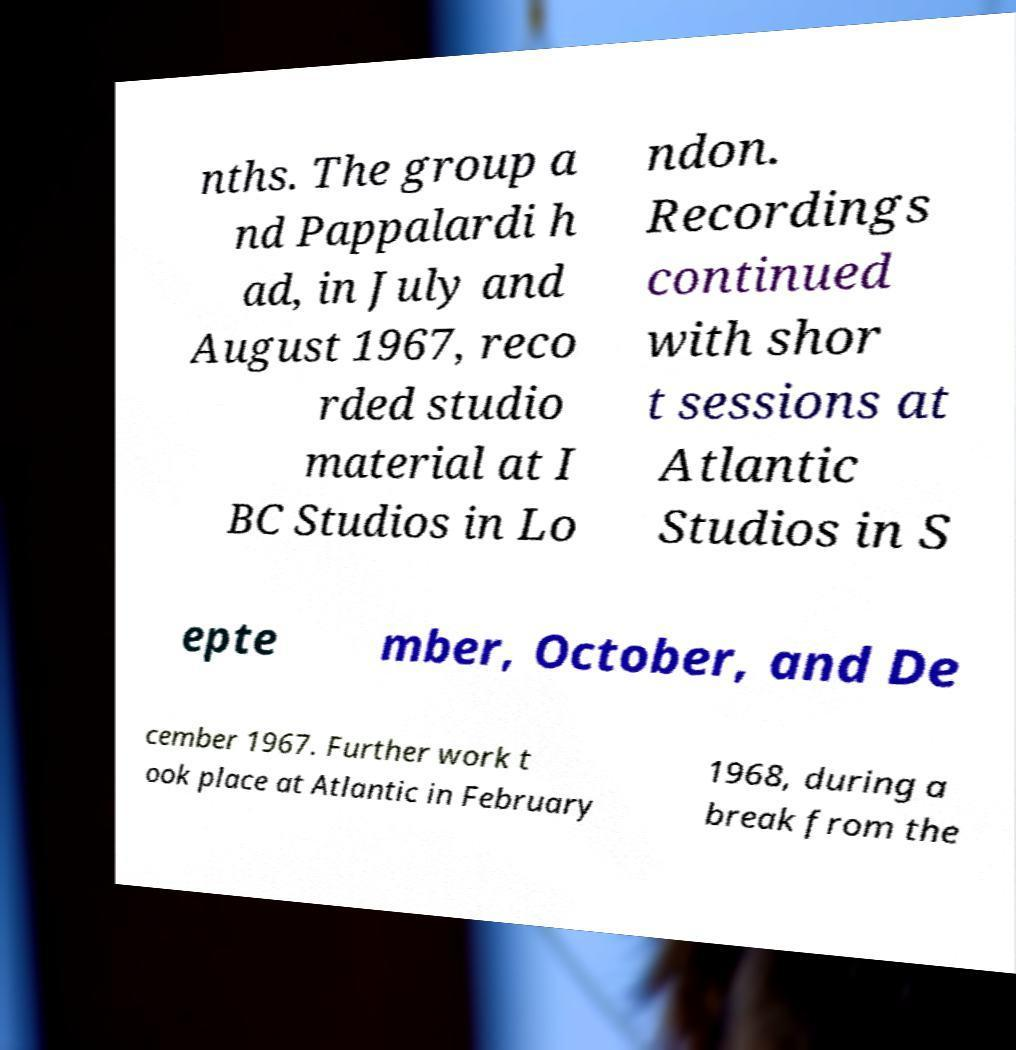Could you assist in decoding the text presented in this image and type it out clearly? nths. The group a nd Pappalardi h ad, in July and August 1967, reco rded studio material at I BC Studios in Lo ndon. Recordings continued with shor t sessions at Atlantic Studios in S epte mber, October, and De cember 1967. Further work t ook place at Atlantic in February 1968, during a break from the 